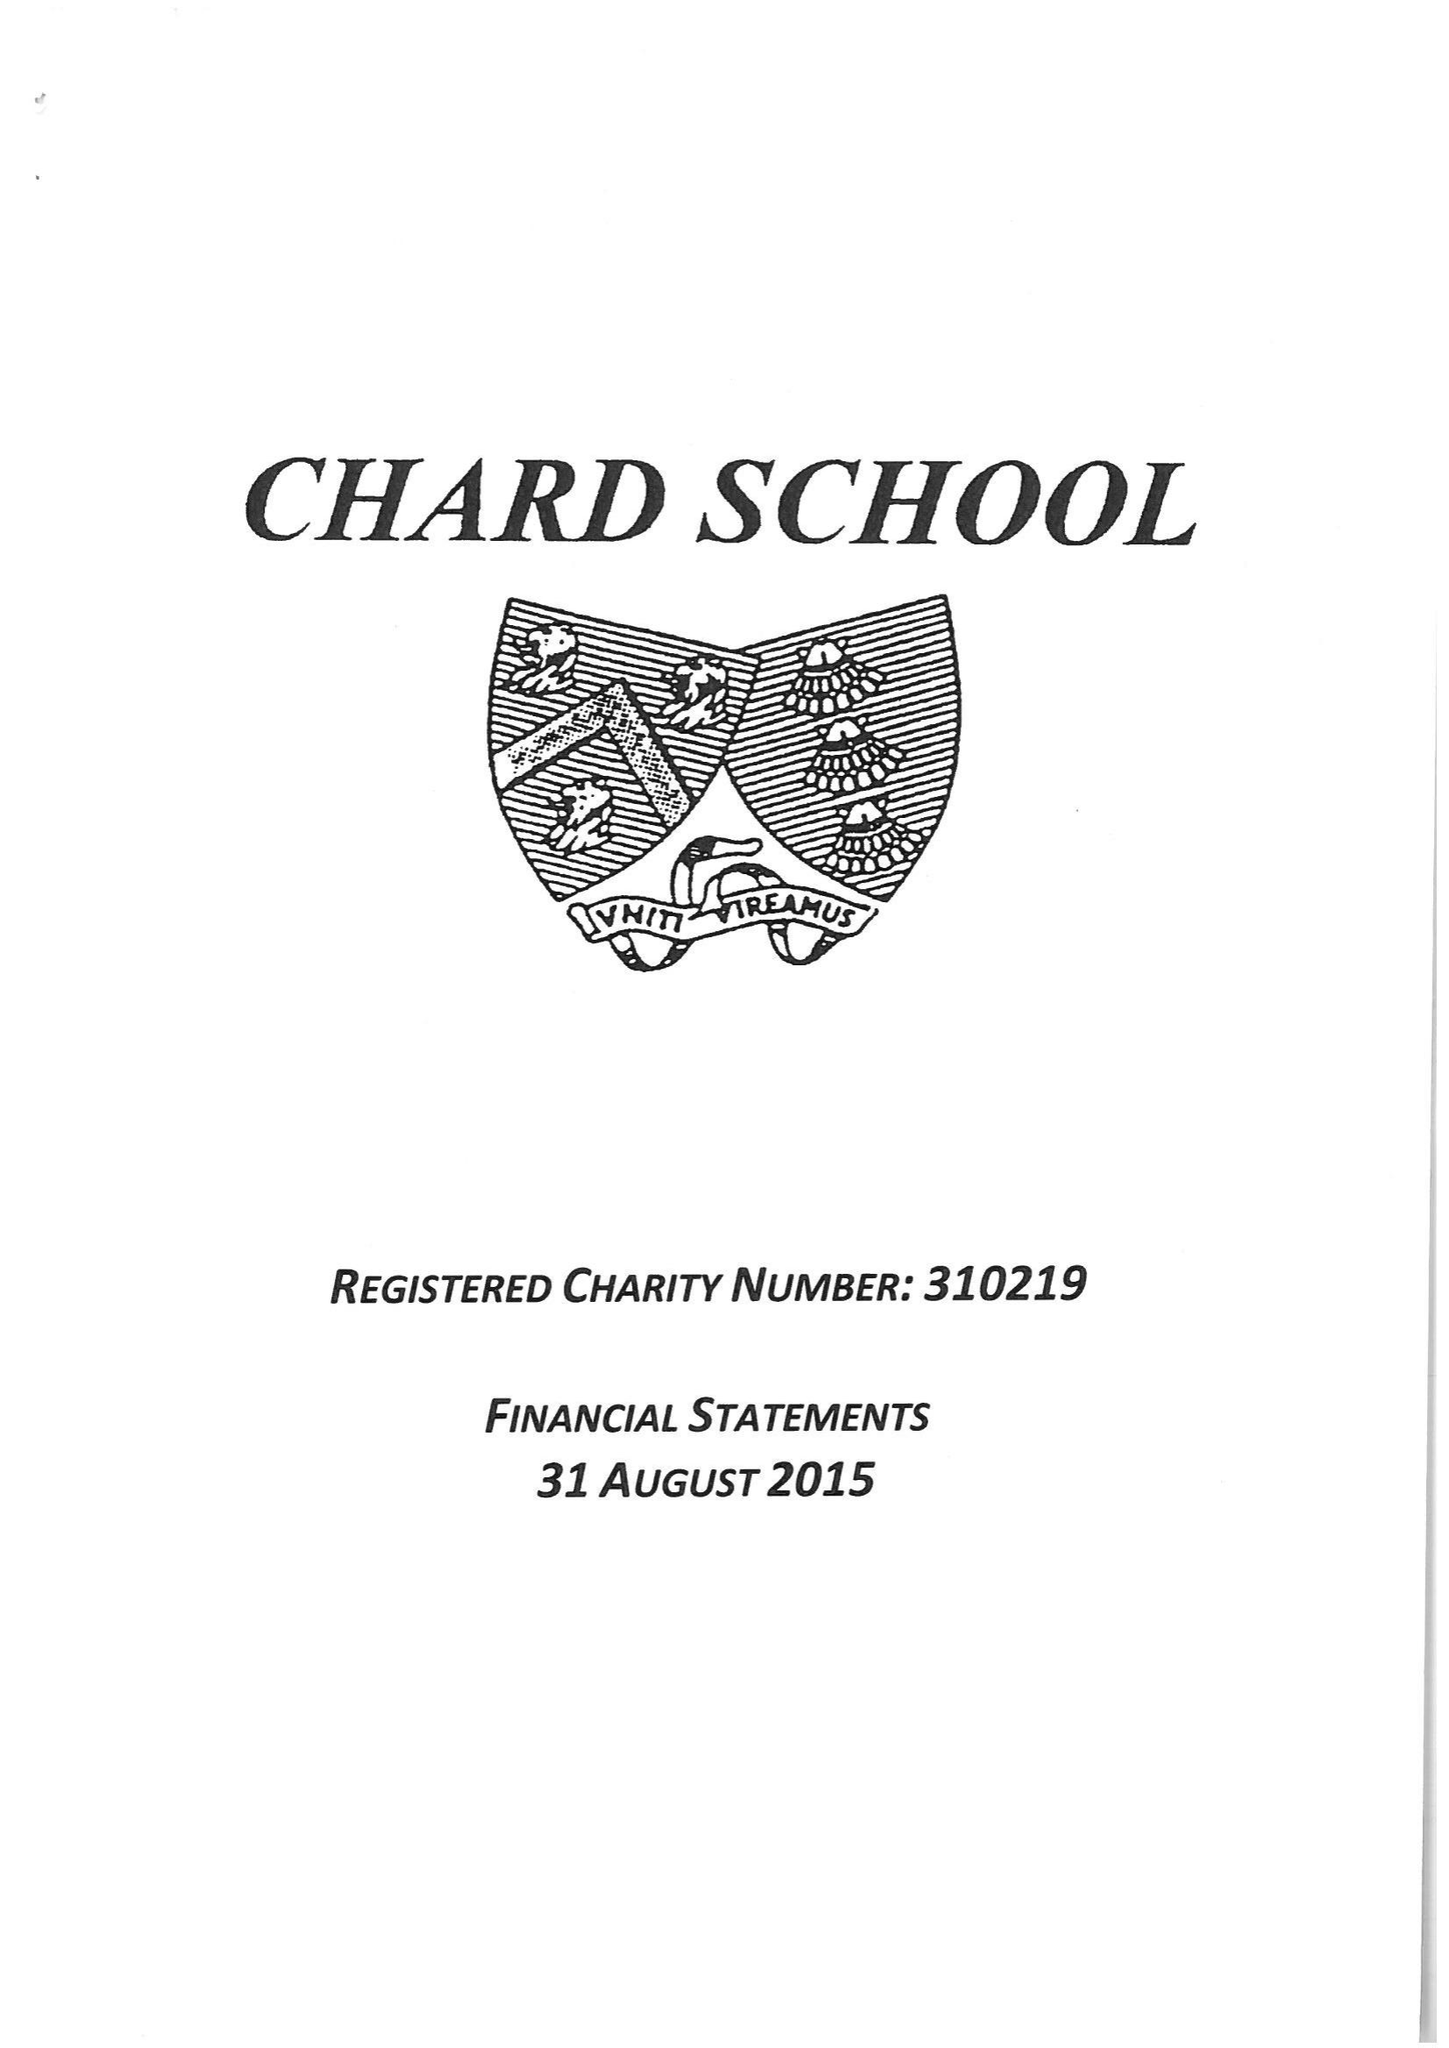What is the value for the address__postcode?
Answer the question using a single word or phrase. TA20 1QA 